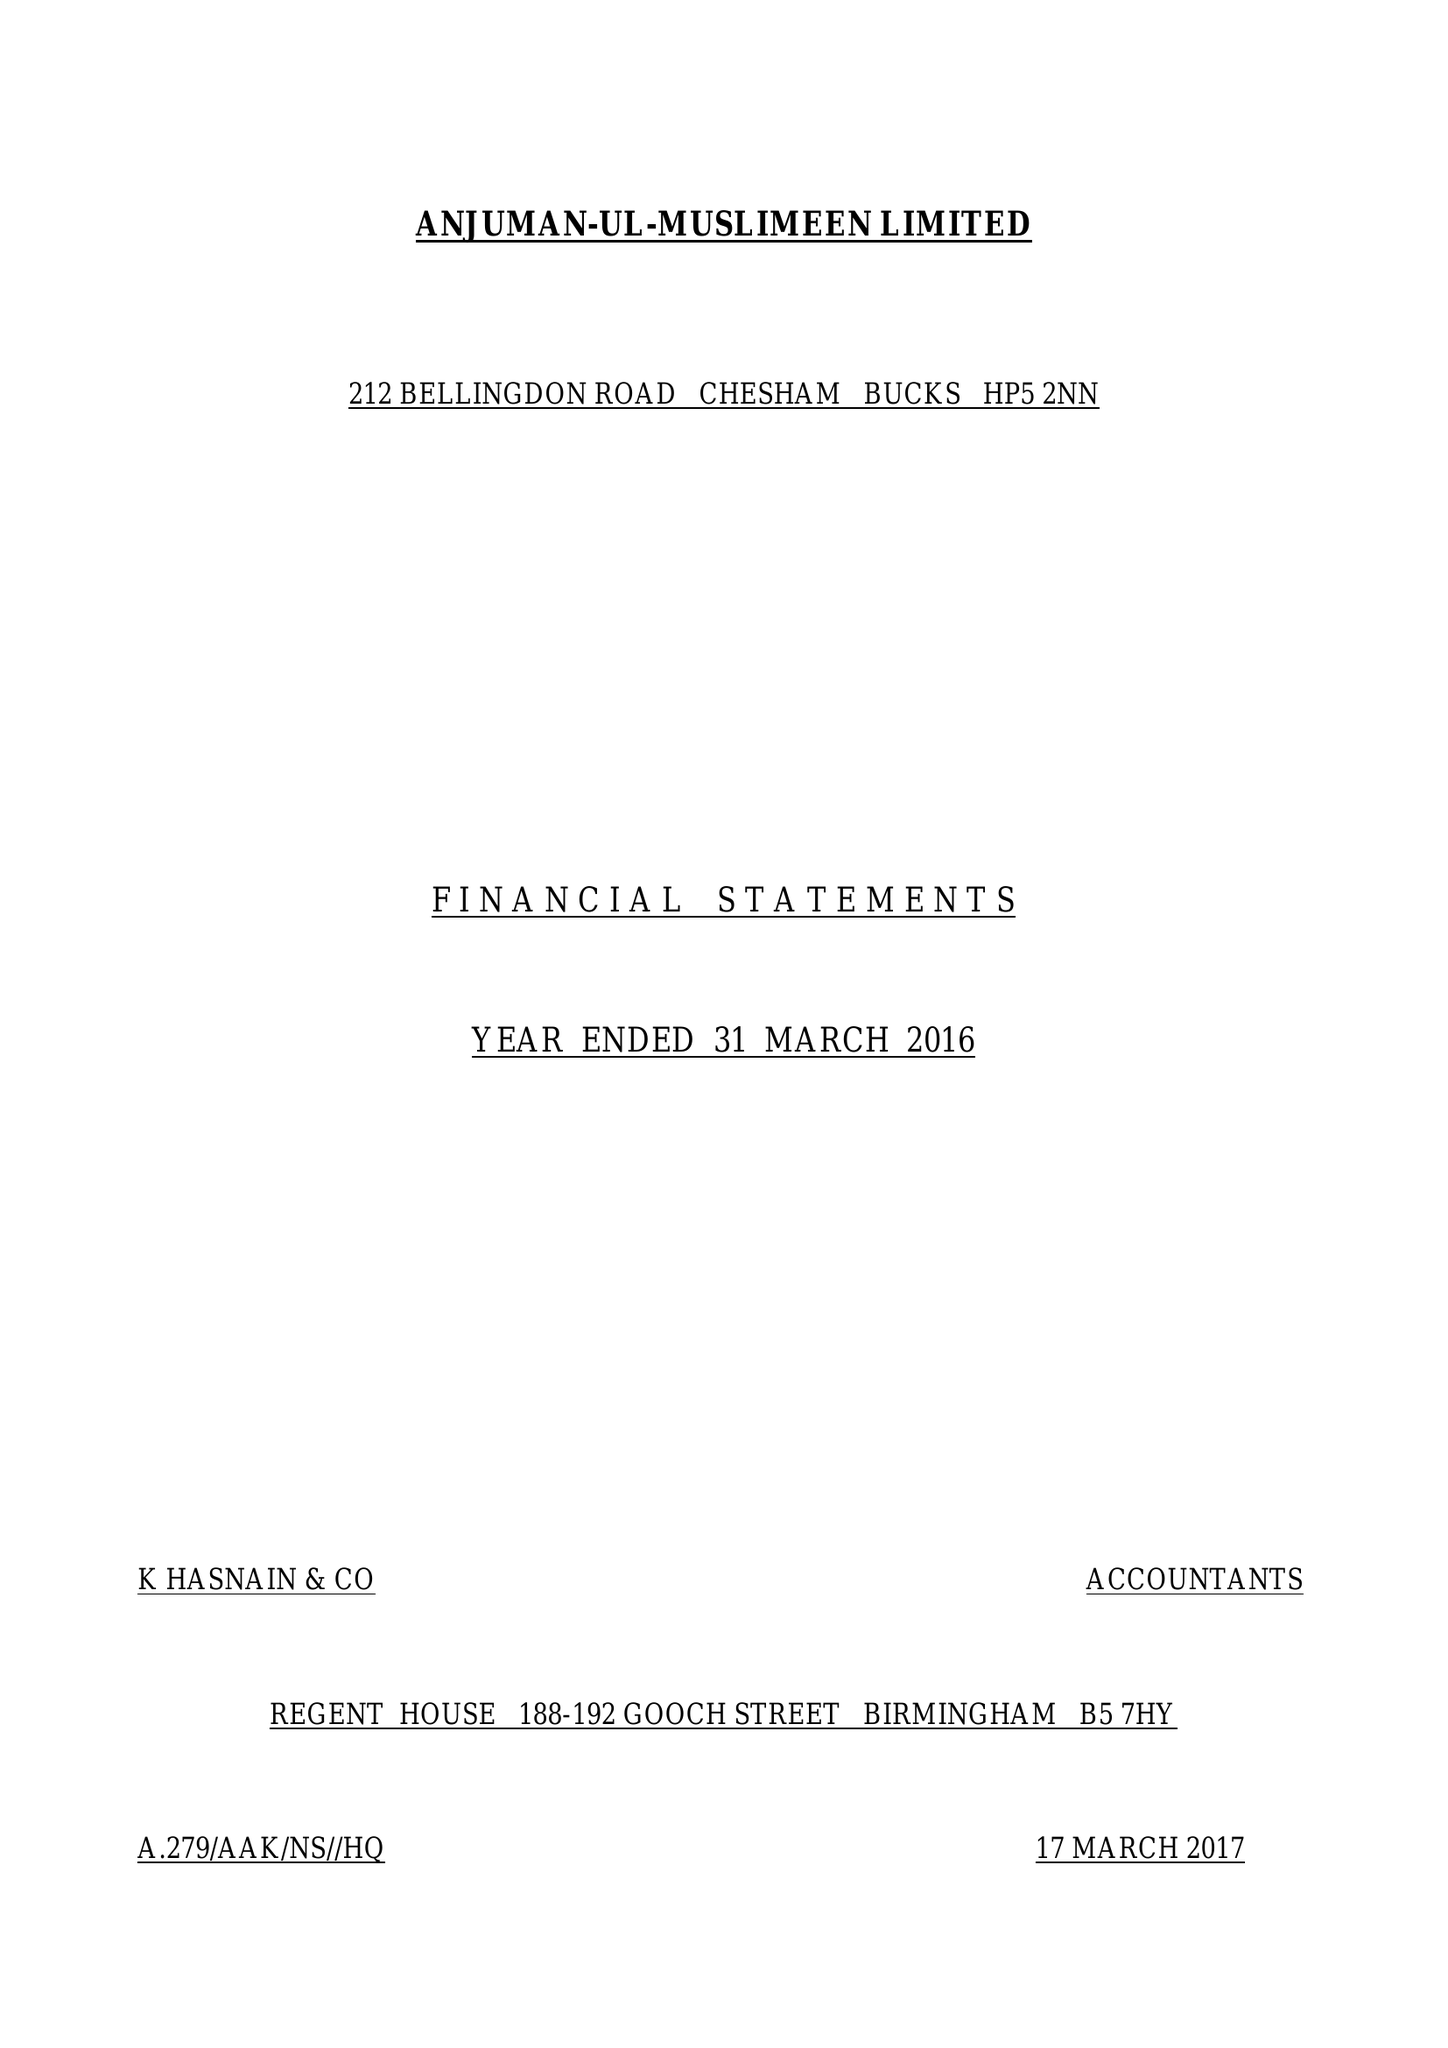What is the value for the charity_number?
Answer the question using a single word or phrase. 262392 